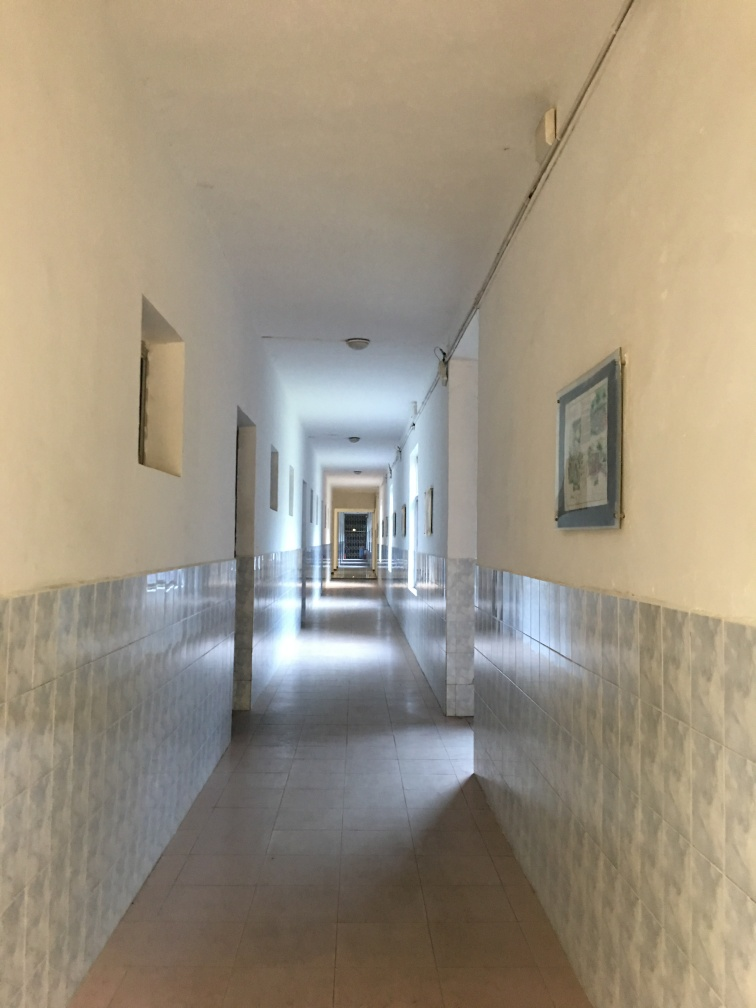Is there anything about the photo that suggests a particular country or region? There are no definitive cultural markers or architectural features in the photo that would suggest a specific country or region. The style is quite universal, although the tiling and the type of light fixtures may provide some clues if compared with localized designs. However, these elements are commonly found in various countries and therefore do not serve as conclusive evidence of a particular locale. 